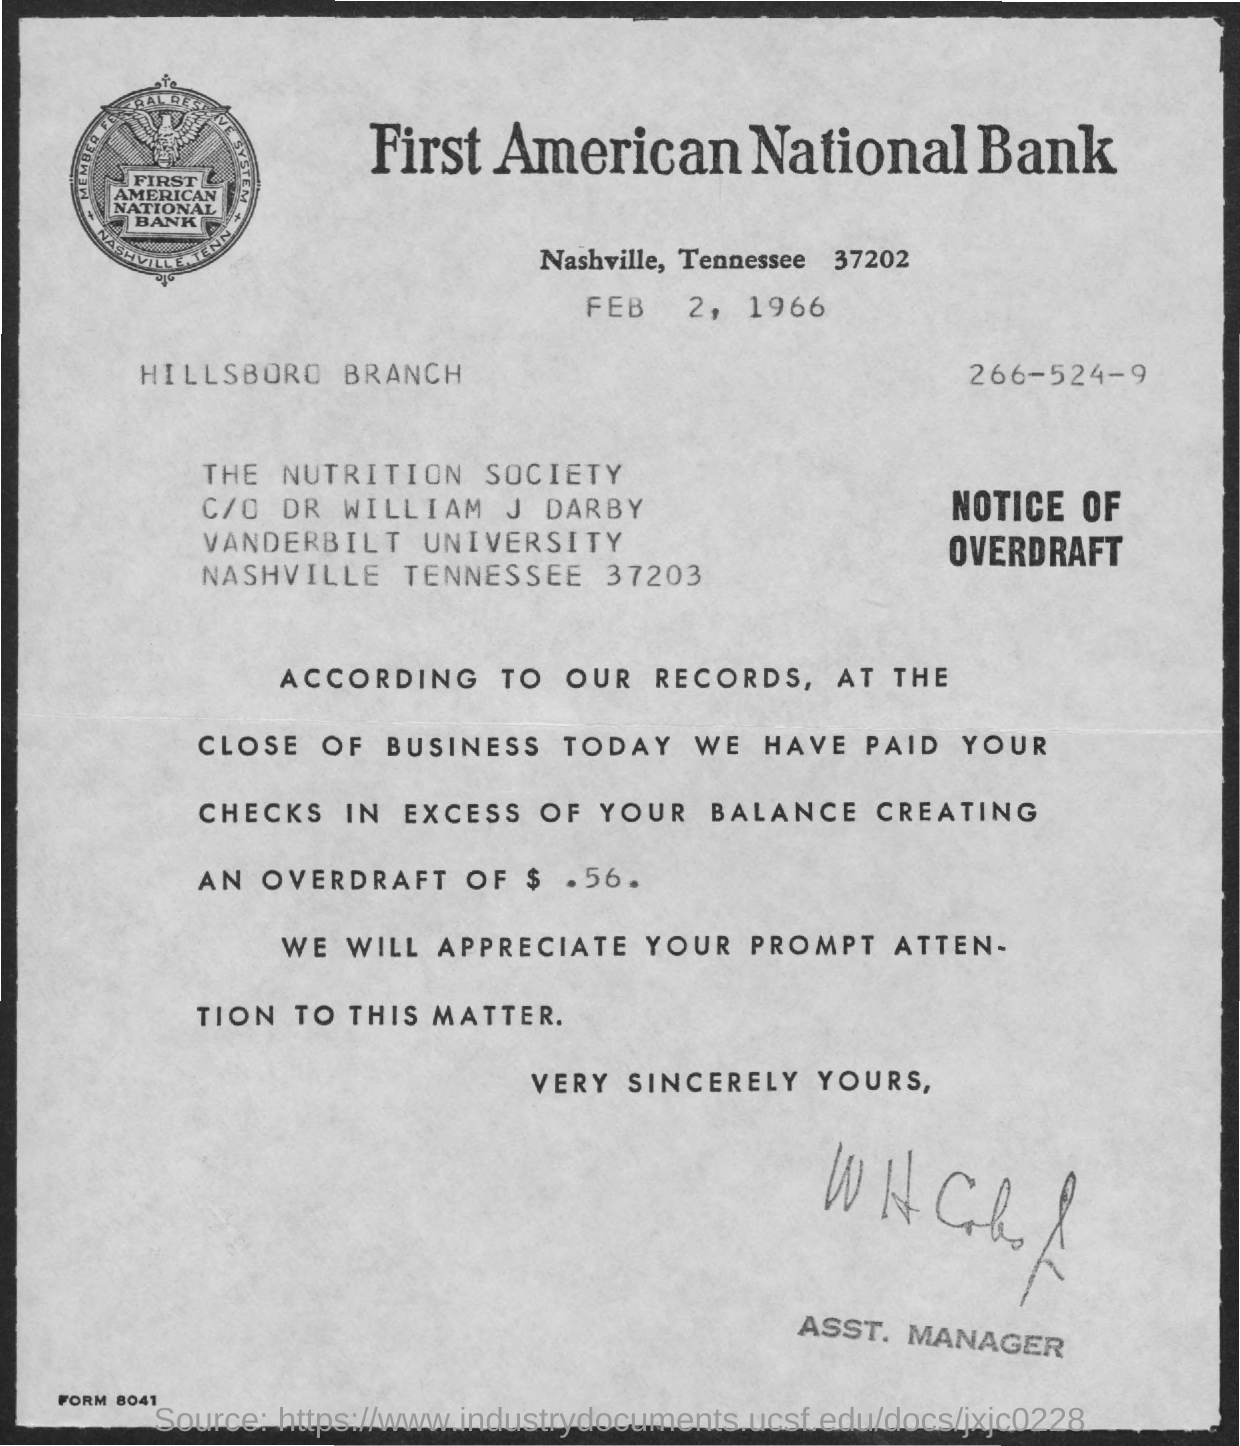What is the date on the document?
Make the answer very short. FEB 2, 1966. How much is the overdraft?
Ensure brevity in your answer.  $ .56. To Whom is this letter addressed to?
Your response must be concise. The Nutrition Society. 